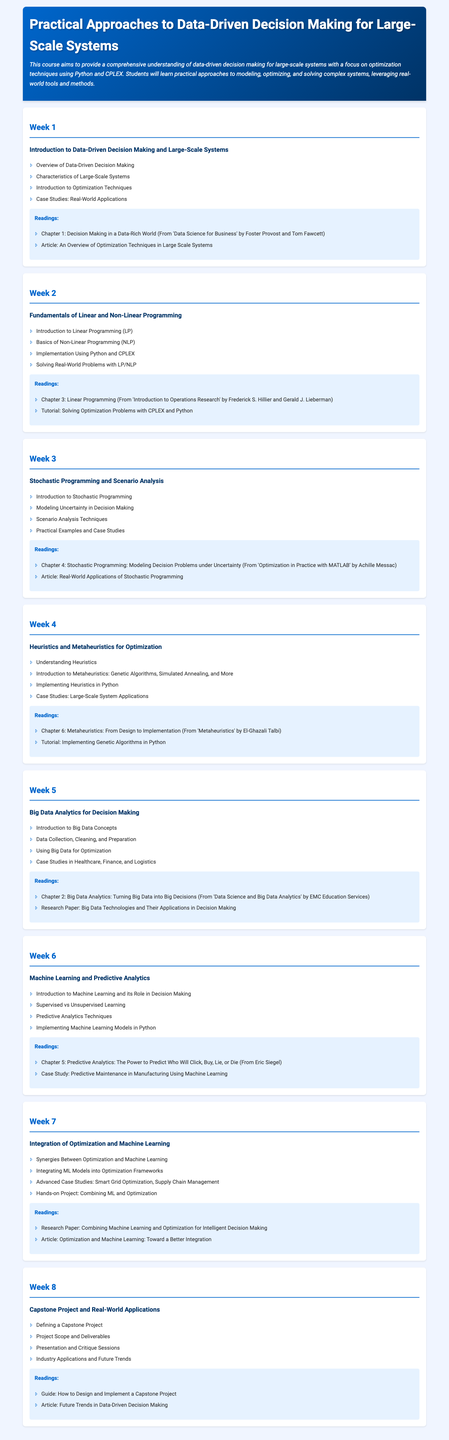What is the title of the course? The title of the course is provided in the header of the document.
Answer: Practical Approaches to Data-Driven Decision Making for Large-Scale Systems Who is the author of the book titled "Data Science for Business"? The author names are mentioned in the readings section, specifically for the first week's reading.
Answer: Foster Provost and Tom Fawcett How many weeks are covered in the syllabus? The syllabus lists the weeks in the main section, which indicates the number of weeks in total.
Answer: 8 Which programming technique is used in Week 2 for solving problems? Week 2 focuses on specific programming techniques mentioned in the content.
Answer: Linear Programming (LP) What type of programming is introduced in Week 3? The topic discussed in Week 3 pertains to a particular programming approach mentioned in the overview.
Answer: Stochastic Programming What heuristic method is introduced in Week 4? The types of methods mentioned in Week 4 specifically relate to optimization techniques.
Answer: Genetic Algorithms What is the main project activity in Week 8? The document specifies project-related activities and outcomes detailed in the final week.
Answer: Capstone Project What chapter discusses Predictive Analytics? The readings section includes specific chapters that discuss various topics, including predictive analytics.
Answer: Chapter 5 